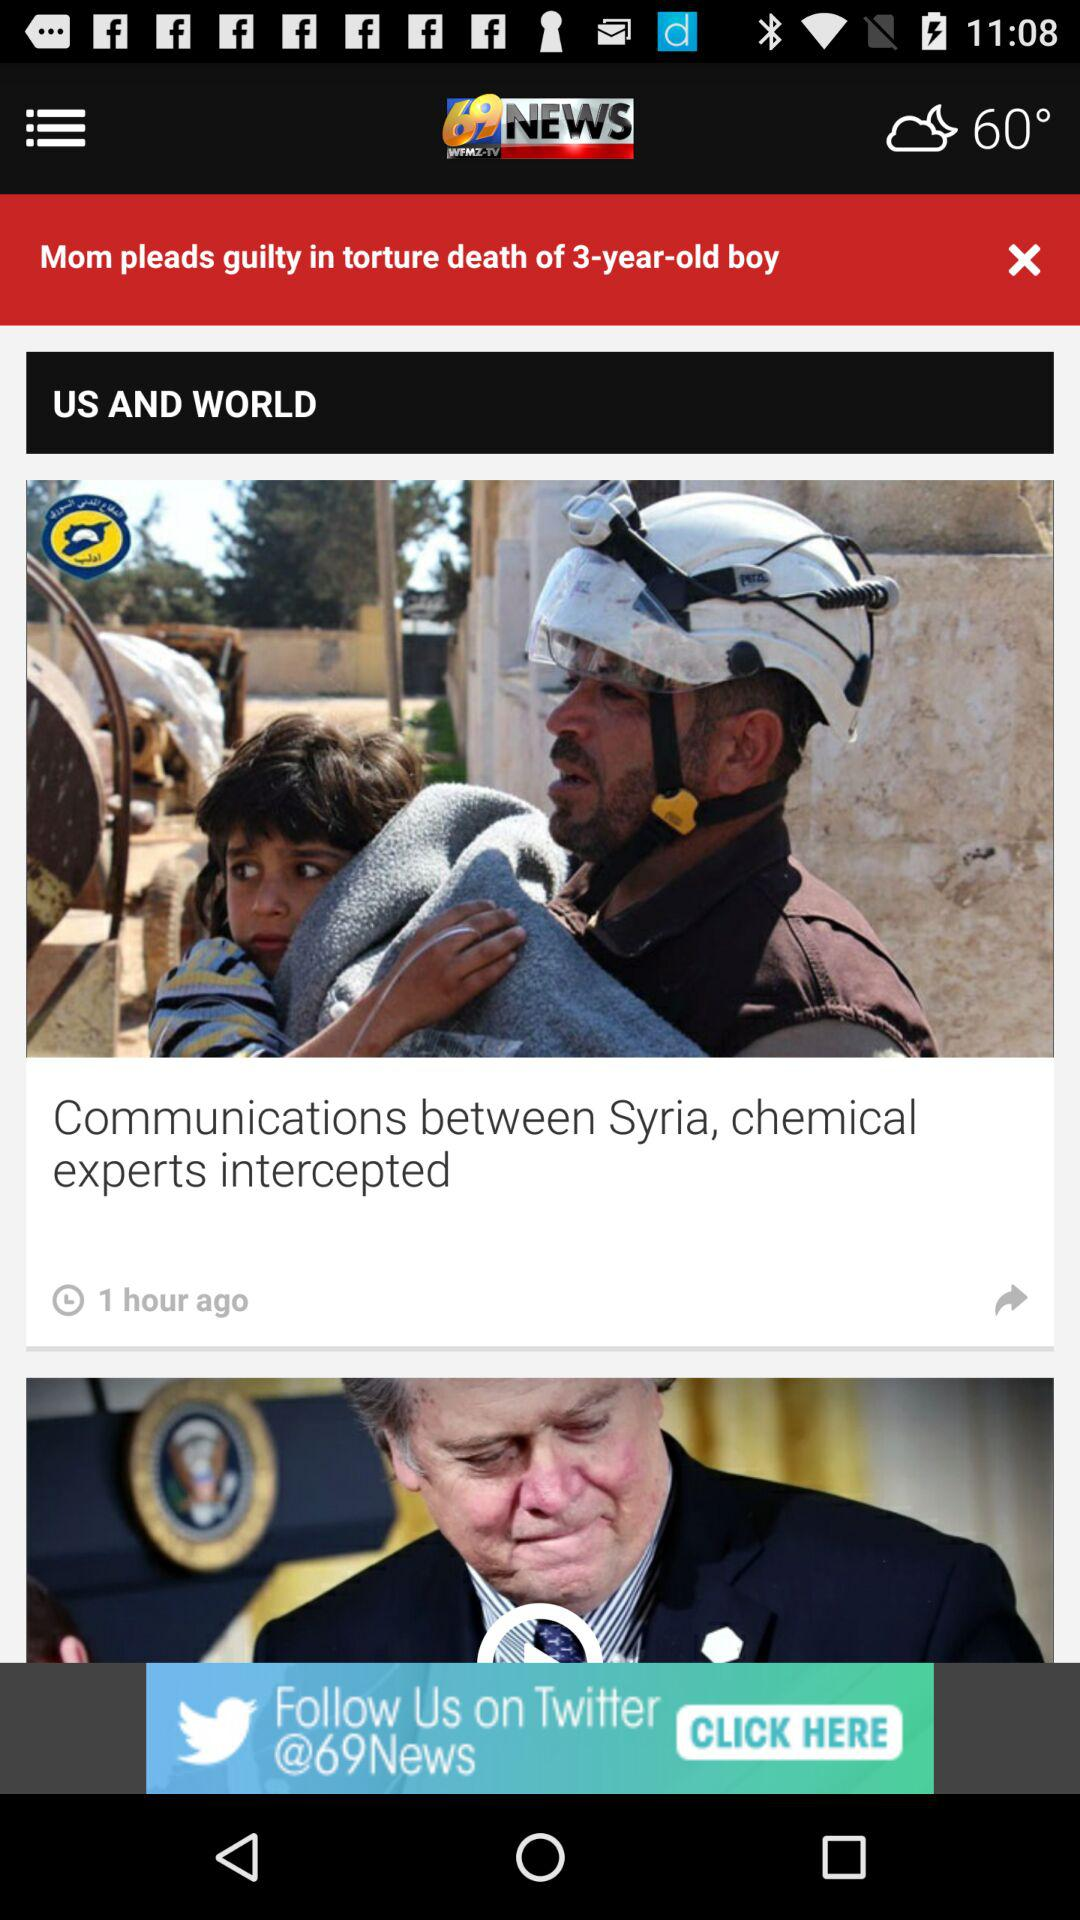What was the age of the boy when he died? The boy was 3 years old when he died. 